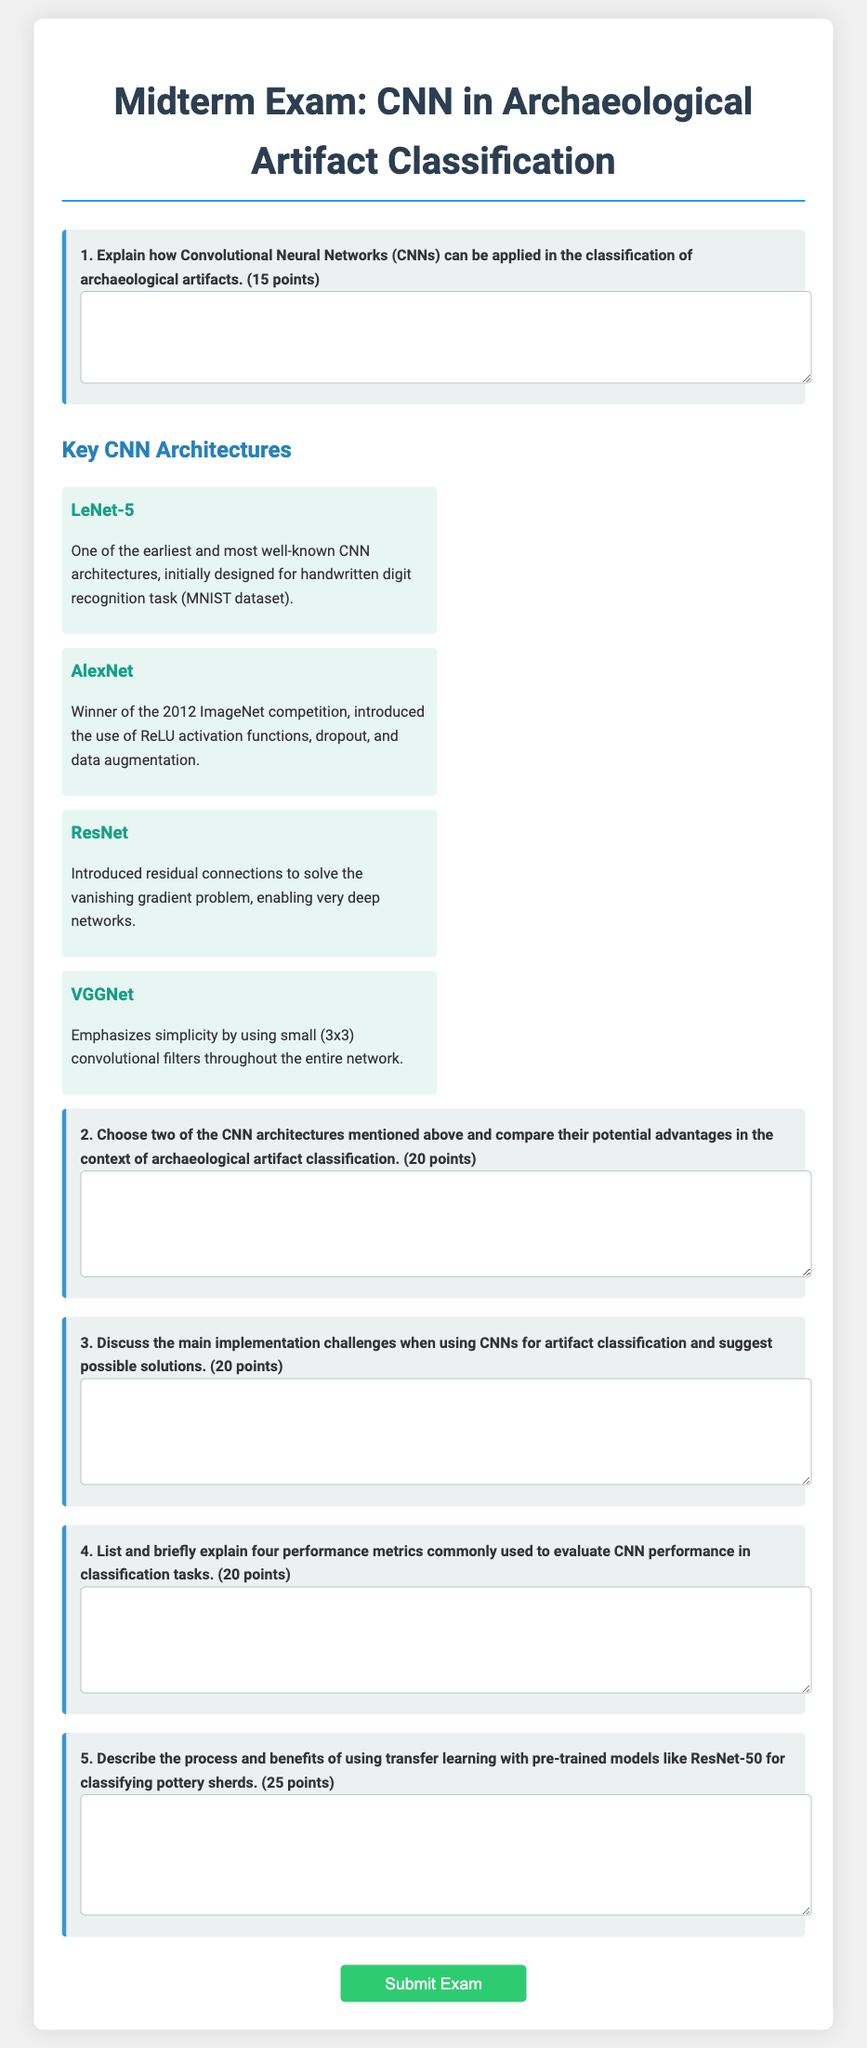What is the title of the exam? The title of the exam is explicitly stated at the beginning of the document.
Answer: Midterm Exam: CNN in Archaeological Artifact Classification How many points is the first question worth? Each question in the exam states how many points it is worth, and the first question specifies it is worth 15 points.
Answer: 15 points What architecture won the 2012 ImageNet competition? The document mentions AlexNet as the winner of the 2012 ImageNet competition.
Answer: AlexNet What is one characteristic of VGGNet? The description provided in the document outlines that VGGNet emphasizes the use of small convolutional filters.
Answer: Small convolutional filters How many architectures are mentioned in the document? The section on key CNN architectures lists four different CNN architectures.
Answer: Four What is the total number of performance metrics requested in the fourth question? The fourth question specifically asks for four performance metrics used to evaluate CNN performance.
Answer: Four What is the total point value of the fifth question? The fifth question indicates that it is worth 25 points.
Answer: 25 points Which architecture introduced residual connections? The description in the document states that ResNet introduced residual connections to solve the vanishing gradient problem.
Answer: ResNet What is the focus of the second question? The second question asks for a comparison of two specific CNN architectures in relation to archaeological artifact classification.
Answer: Comparison of two CNN architectures 